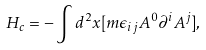Convert formula to latex. <formula><loc_0><loc_0><loc_500><loc_500>H _ { c } = - \int d ^ { 2 } x [ m \epsilon _ { i j } A ^ { 0 } \partial ^ { i } A ^ { j } ] ,</formula> 